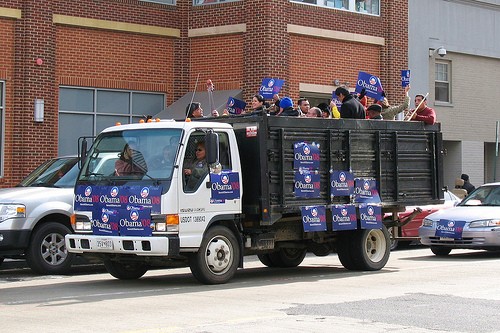Please provide a short description for this region: [0.22, 0.45, 0.3, 0.52]. A woman in the windshield on the left side is wearing a pink striped shirt. 